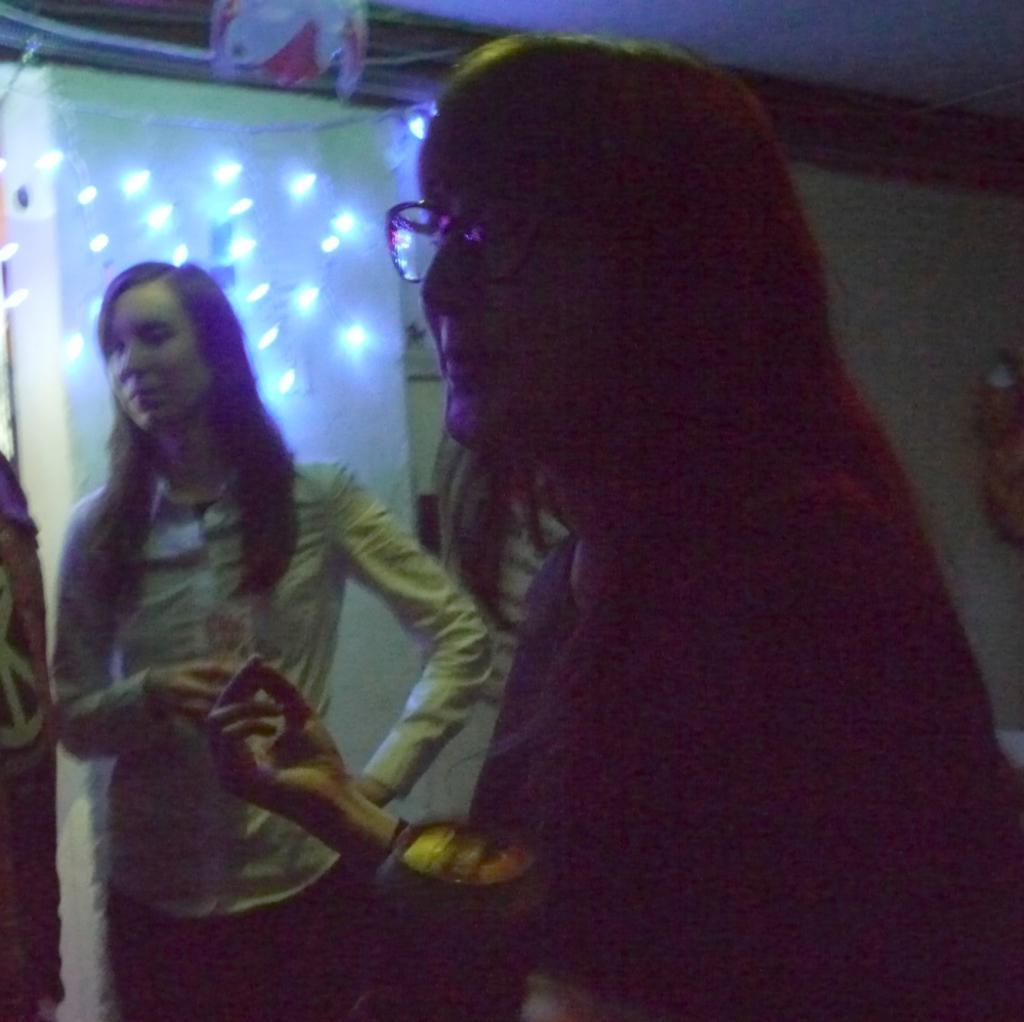Please provide a concise description of this image. This image is taken during night time. In this image we can see two women. In the background there is a pillar and also lights. We can also see some part of ceiling. 